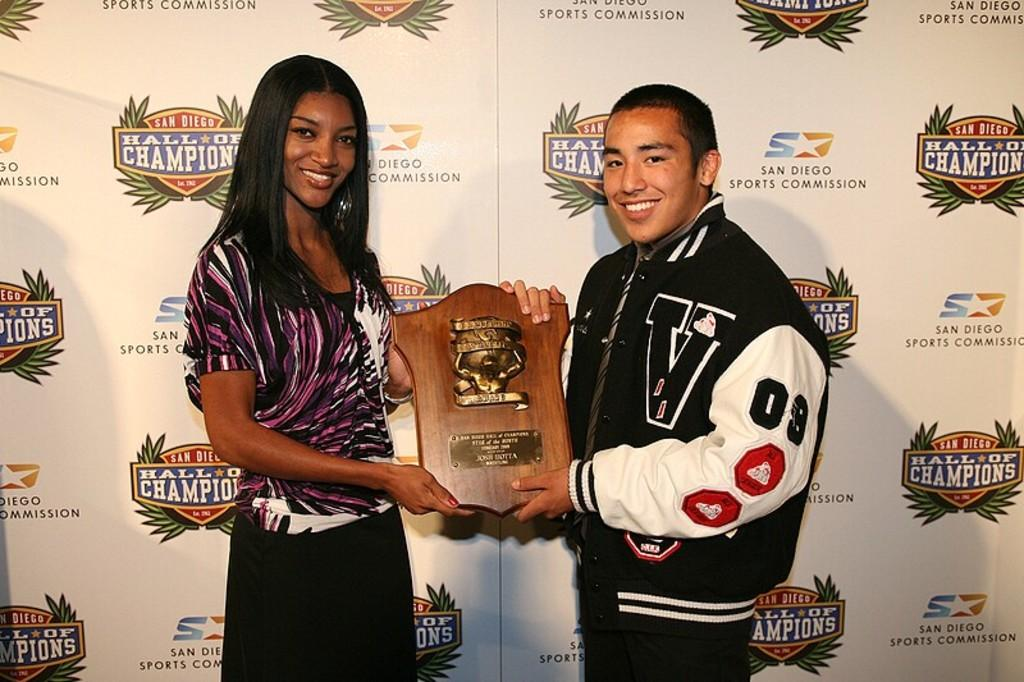<image>
Write a terse but informative summary of the picture. A young woman and a young man in a varsity jacket stand in front of a backdrop with the San Diego Hall of Champions logo on it. 